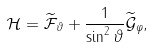<formula> <loc_0><loc_0><loc_500><loc_500>\mathcal { H } = \widetilde { \mathcal { F } } _ { \vartheta } + \frac { 1 } { \sin ^ { 2 } \vartheta } \widetilde { \mathcal { G } } _ { \varphi } ,</formula> 